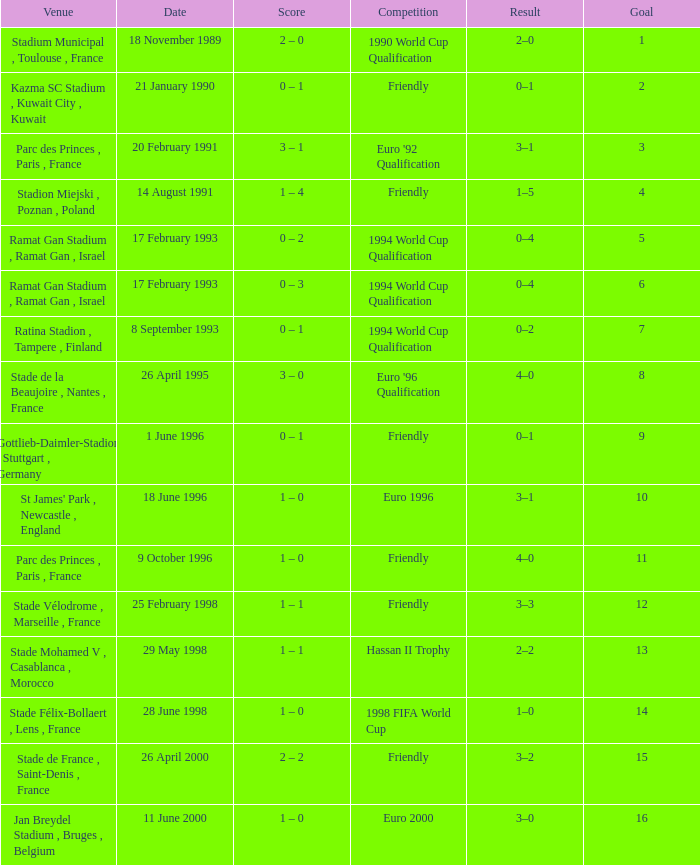What was the date of the game with a result of 3–2? 26 April 2000. 